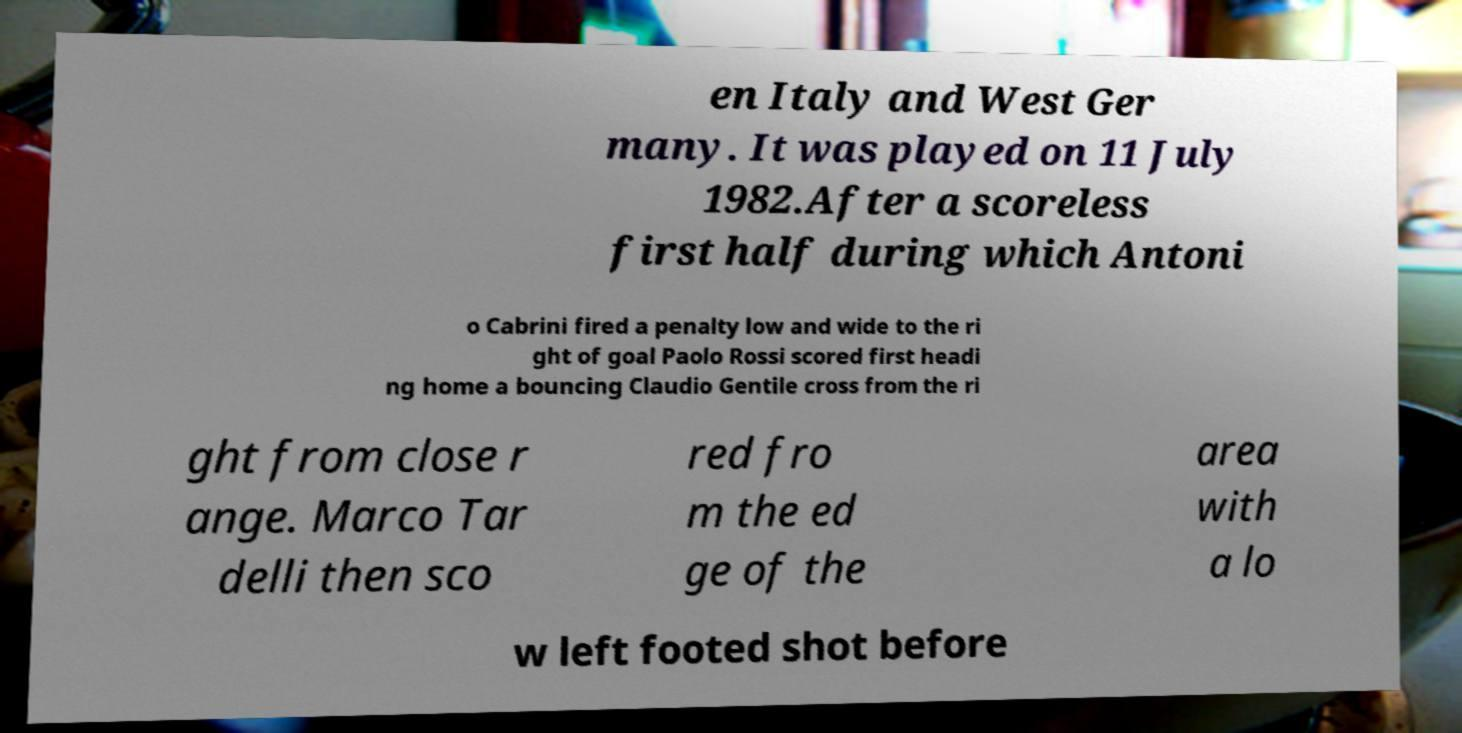I need the written content from this picture converted into text. Can you do that? en Italy and West Ger many. It was played on 11 July 1982.After a scoreless first half during which Antoni o Cabrini fired a penalty low and wide to the ri ght of goal Paolo Rossi scored first headi ng home a bouncing Claudio Gentile cross from the ri ght from close r ange. Marco Tar delli then sco red fro m the ed ge of the area with a lo w left footed shot before 